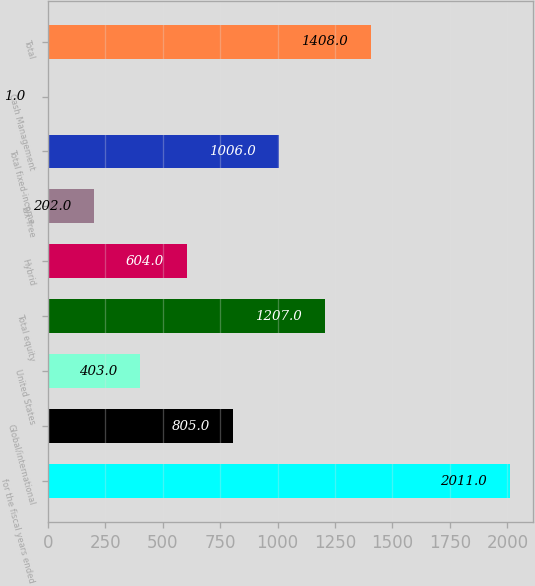<chart> <loc_0><loc_0><loc_500><loc_500><bar_chart><fcel>for the fiscal years ended<fcel>Global/international<fcel>United States<fcel>Total equity<fcel>Hybrid<fcel>Tax-free<fcel>Total fixed-income<fcel>Cash Management<fcel>Total<nl><fcel>2011<fcel>805<fcel>403<fcel>1207<fcel>604<fcel>202<fcel>1006<fcel>1<fcel>1408<nl></chart> 